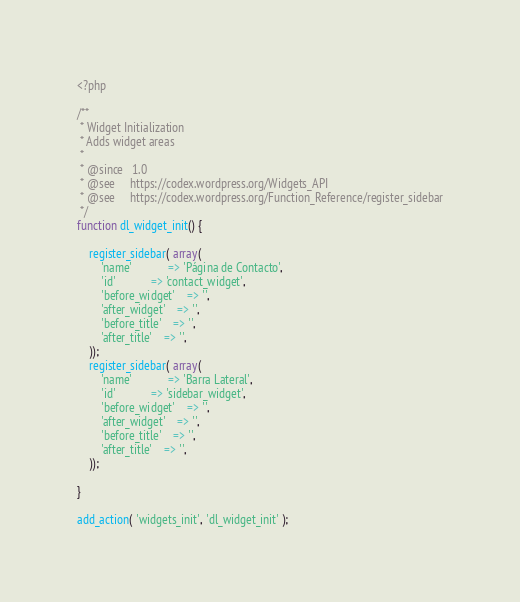<code> <loc_0><loc_0><loc_500><loc_500><_PHP_><?php

/**
 * Widget Initialization
 * Adds widget areas
 *
 * @since   1.0
 * @see     https://codex.wordpress.org/Widgets_API
 * @see     https://codex.wordpress.org/Function_Reference/register_sidebar
 */
function dl_widget_init() {

	register_sidebar( array(
		'name'			=> 'Página de Contacto',
		'id'			=> 'contact_widget',
		'before_widget'	=> '',
		'after_widget'	=> '',
		'before_title'	=> '',
		'after_title'	=> '',
	));
	register_sidebar( array(
		'name'			=> 'Barra Lateral',
		'id'			=> 'sidebar_widget',
		'before_widget'	=> '',
		'after_widget'	=> '',
		'before_title'	=> '',
		'after_title'	=> '',
	));

}

add_action( 'widgets_init', 'dl_widget_init' );
</code> 